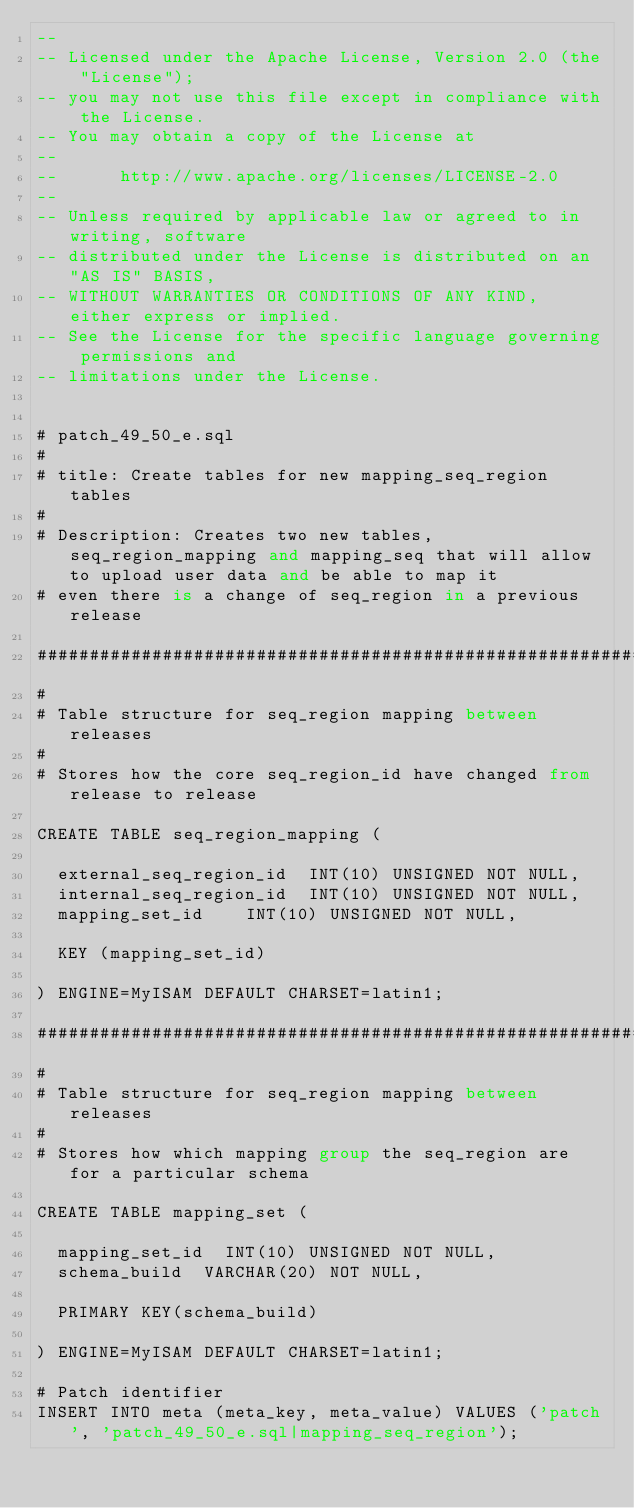Convert code to text. <code><loc_0><loc_0><loc_500><loc_500><_SQL_>-- 
-- Licensed under the Apache License, Version 2.0 (the "License");
-- you may not use this file except in compliance with the License.
-- You may obtain a copy of the License at
-- 
--      http://www.apache.org/licenses/LICENSE-2.0
-- 
-- Unless required by applicable law or agreed to in writing, software
-- distributed under the License is distributed on an "AS IS" BASIS,
-- WITHOUT WARRANTIES OR CONDITIONS OF ANY KIND, either express or implied.
-- See the License for the specific language governing permissions and
-- limitations under the License.


# patch_49_50_e.sql
#
# title: Create tables for new mapping_seq_region tables
#
# Description: Creates two new tables, seq_region_mapping and mapping_seq that will allow to upload user data and be able to map it
# even there is a change of seq_region in a previous release

################################################################################
#
# Table structure for seq_region mapping between releases
#
# Stores how the core seq_region_id have changed from release to release

CREATE TABLE seq_region_mapping (

	external_seq_region_id	INT(10) UNSIGNED NOT NULL,
	internal_seq_region_id	INT(10) UNSIGNED NOT NULL,
	mapping_set_id		INT(10) UNSIGNED NOT NULL,

	KEY (mapping_set_id)

) ENGINE=MyISAM DEFAULT CHARSET=latin1;

################################################################################
#
# Table structure for seq_region mapping between releases
#
# Stores how which mapping group the seq_region are for a particular schema

CREATE TABLE mapping_set (

	mapping_set_id	INT(10)	UNSIGNED NOT NULL,
	schema_build	VARCHAR(20) NOT NULL,

	PRIMARY KEY(schema_build)

) ENGINE=MyISAM DEFAULT CHARSET=latin1;

# Patch identifier
INSERT INTO meta (meta_key, meta_value) VALUES ('patch', 'patch_49_50_e.sql|mapping_seq_region');



</code> 